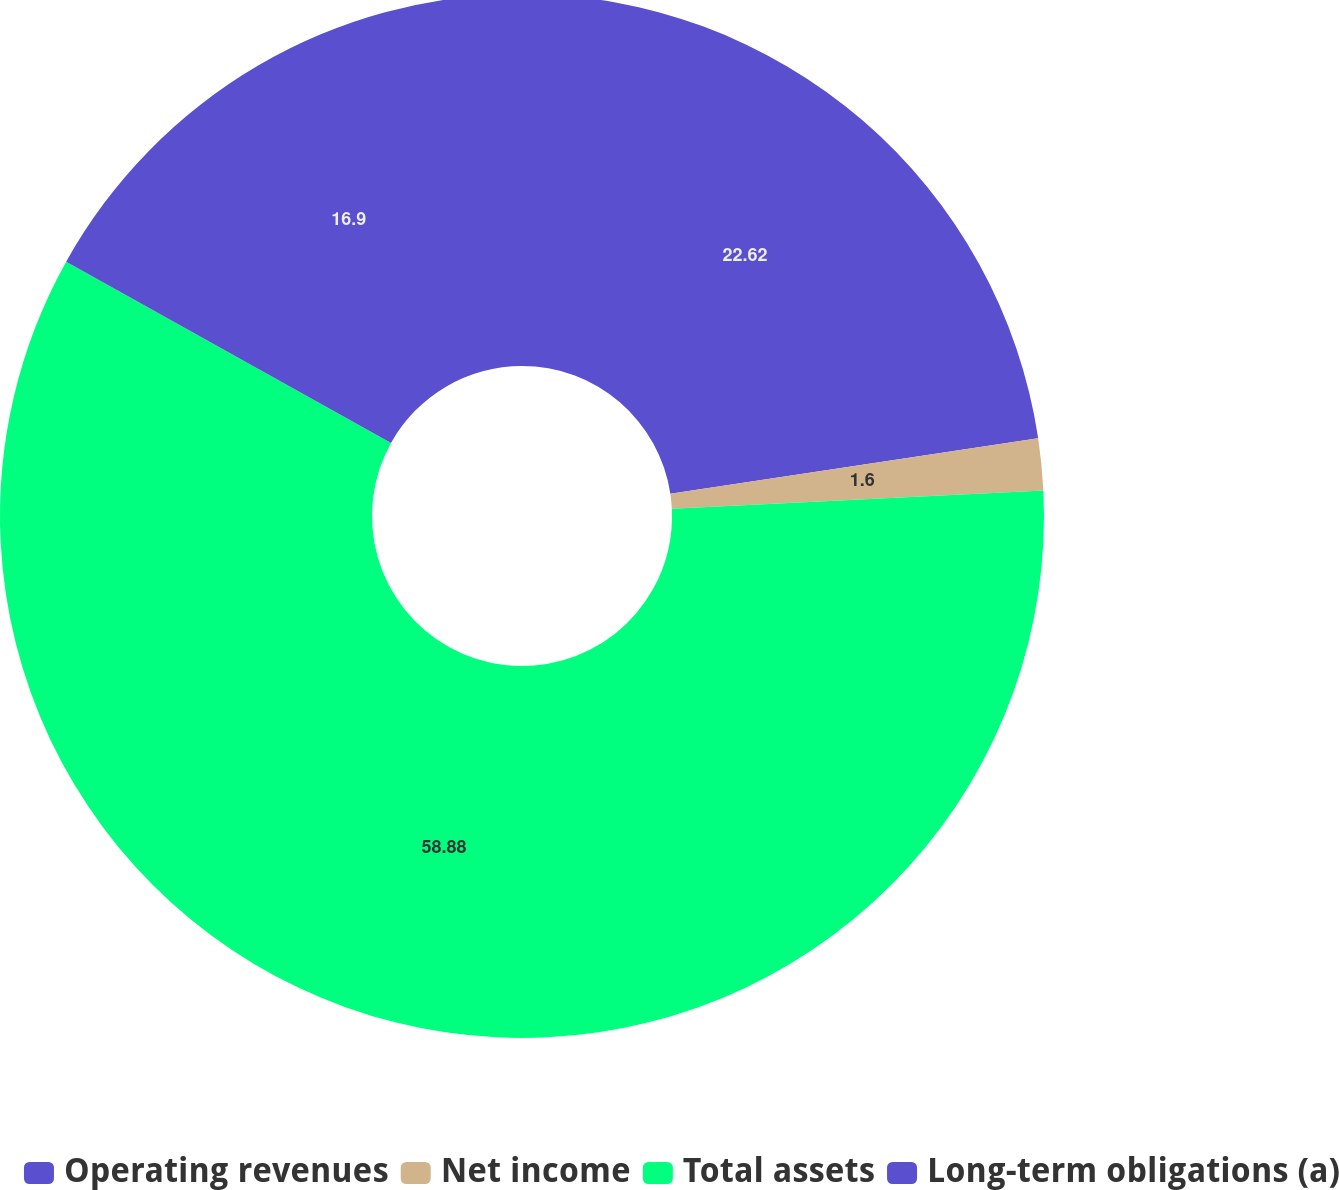Convert chart to OTSL. <chart><loc_0><loc_0><loc_500><loc_500><pie_chart><fcel>Operating revenues<fcel>Net income<fcel>Total assets<fcel>Long-term obligations (a)<nl><fcel>22.62%<fcel>1.6%<fcel>58.88%<fcel>16.9%<nl></chart> 